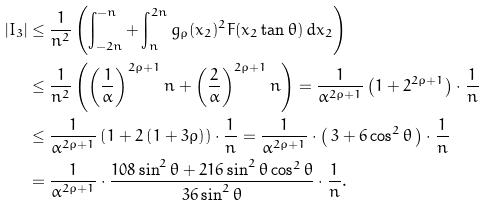<formula> <loc_0><loc_0><loc_500><loc_500>| I _ { 3 } | & \leq \frac { 1 } { n ^ { 2 } } \left ( \int _ { - 2 n } ^ { - n } + \int _ { n } ^ { 2 n } g _ { \rho } ( x _ { 2 } ) ^ { 2 } F ( x _ { 2 } \tan \theta ) \, d x _ { 2 } \right ) \\ & \leq \frac { 1 } { n ^ { 2 } } \left ( \left ( \frac { 1 } { \alpha } \right ) ^ { 2 \rho + 1 } n + \left ( \frac { 2 } { \alpha } \right ) ^ { 2 \rho + 1 } n \right ) = \frac { 1 } { \alpha ^ { 2 \rho + 1 } } \left ( 1 + 2 ^ { 2 \rho + 1 } \right ) \cdot \frac { 1 } { n } \\ & \leq \frac { 1 } { \alpha ^ { 2 \rho + 1 } } \left ( 1 + 2 \left ( 1 + 3 \rho \right ) \right ) \cdot \frac { 1 } { n } = \frac { 1 } { \alpha ^ { 2 \rho + 1 } } \cdot \left ( \, 3 + 6 \cos ^ { 2 } \theta \, \right ) \cdot \frac { 1 } { n } \\ & = \frac { 1 } { \alpha ^ { 2 \rho + 1 } } \cdot \frac { 1 0 8 \sin ^ { 2 } \theta + 2 1 6 \sin ^ { 2 } \theta \cos ^ { 2 } \theta } { 3 6 \sin ^ { 2 } \theta } \cdot \frac { 1 } { n } .</formula> 